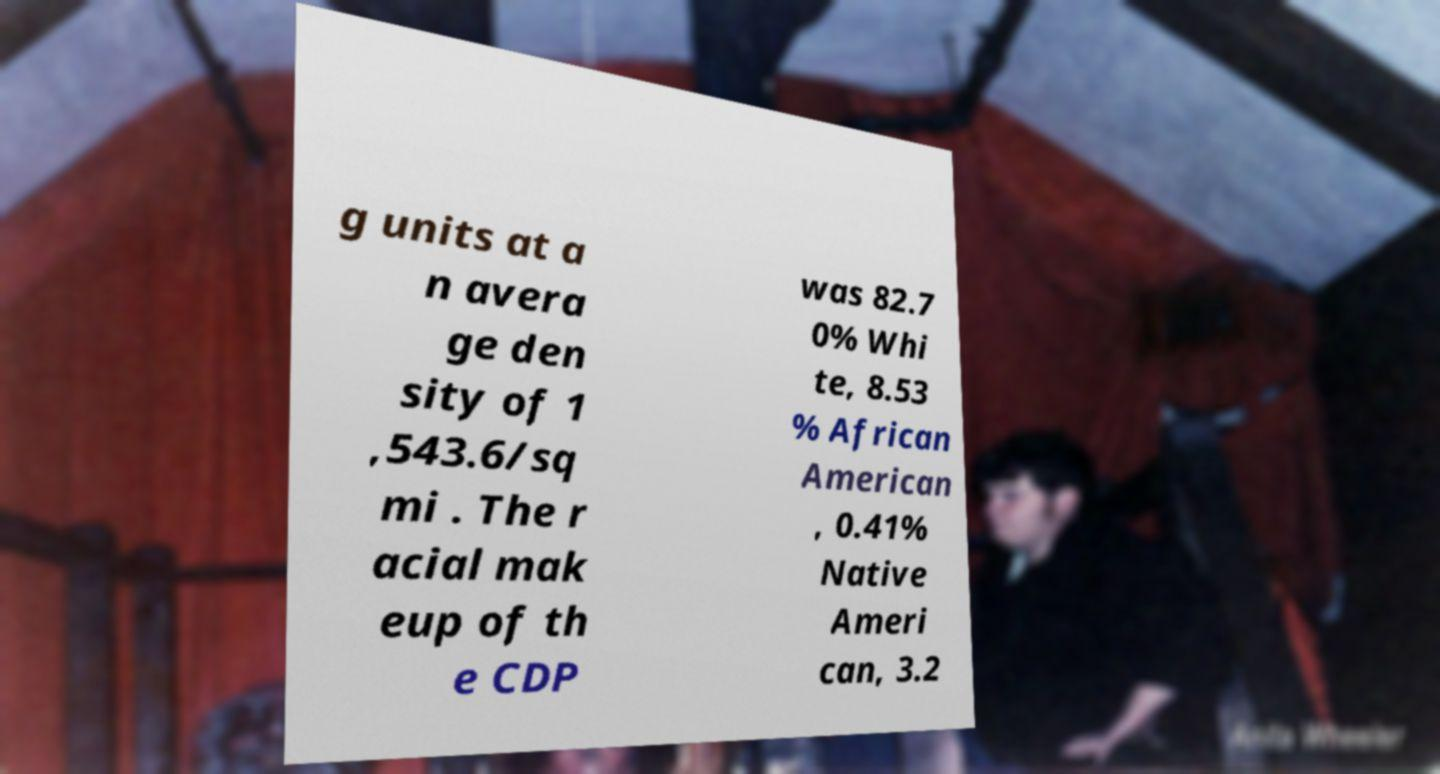There's text embedded in this image that I need extracted. Can you transcribe it verbatim? g units at a n avera ge den sity of 1 ,543.6/sq mi . The r acial mak eup of th e CDP was 82.7 0% Whi te, 8.53 % African American , 0.41% Native Ameri can, 3.2 